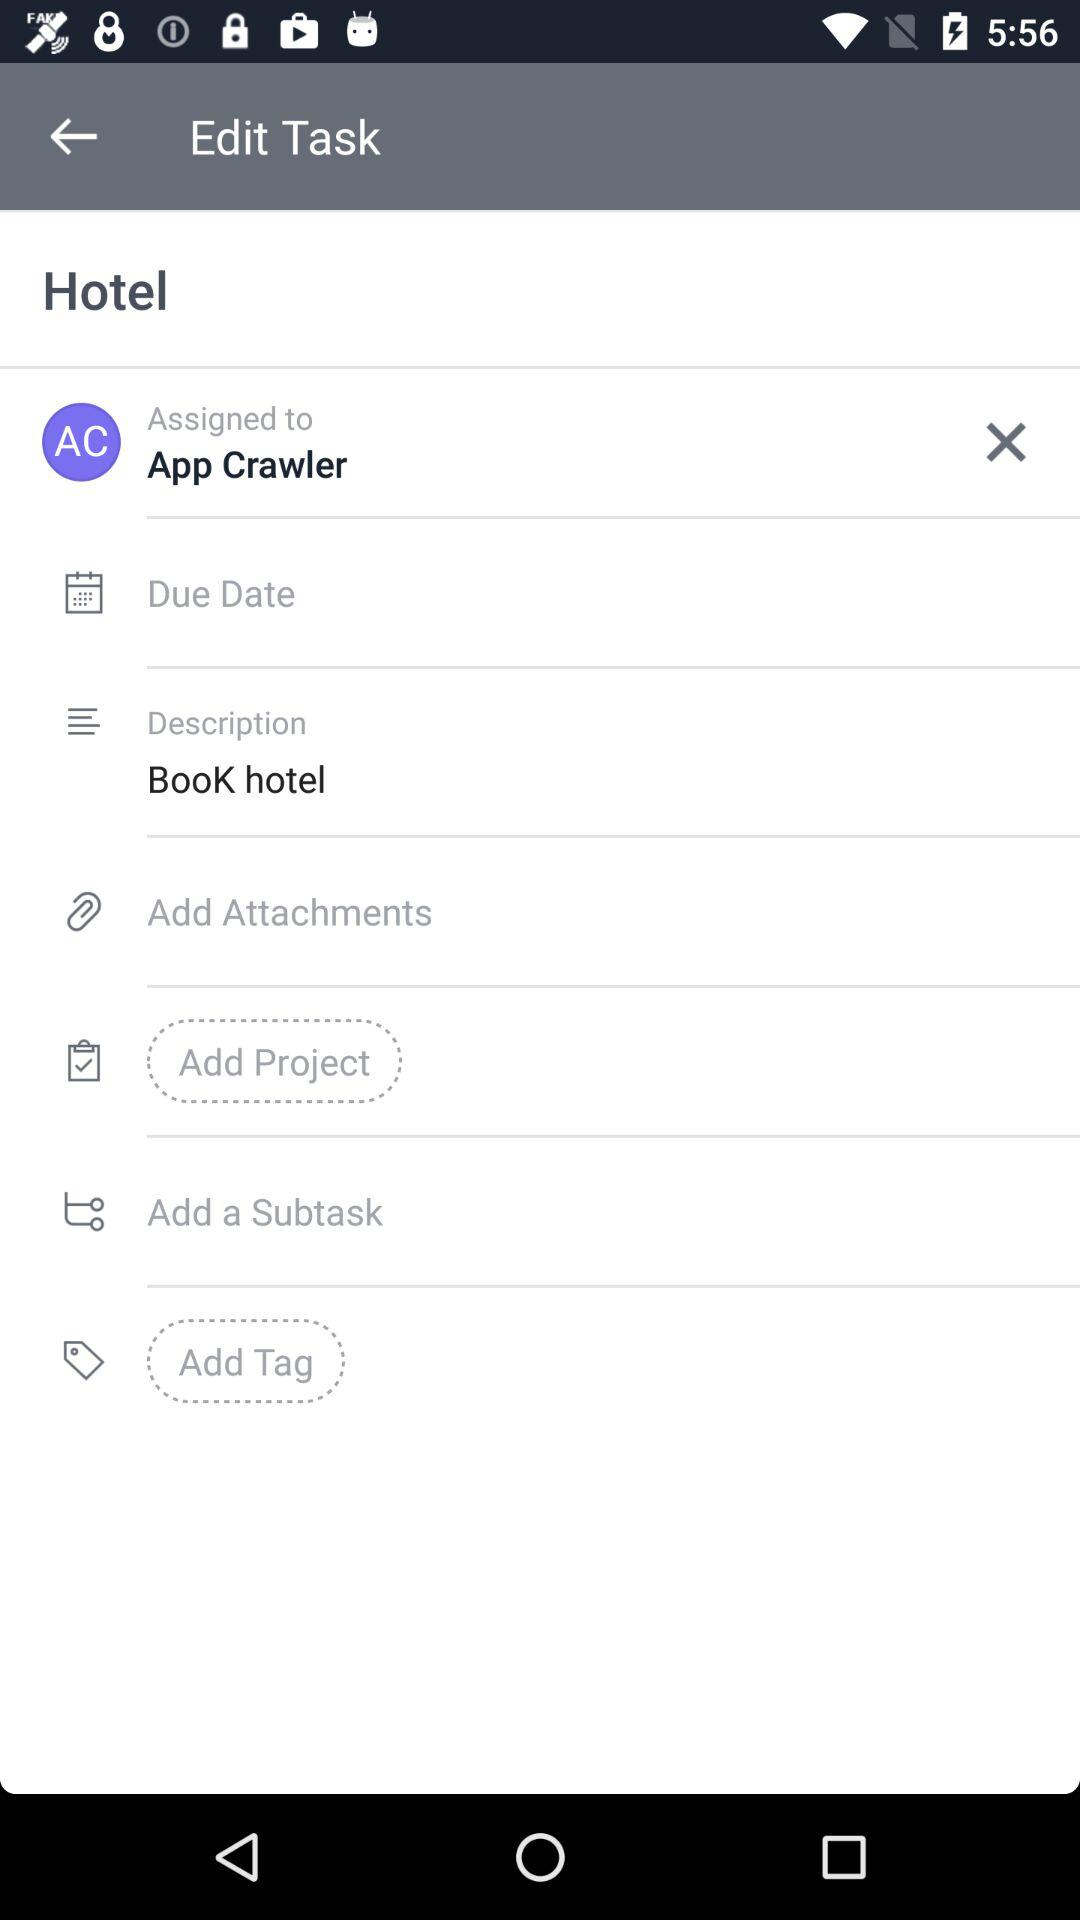What is the description of the task? The description is "Book hotel". 